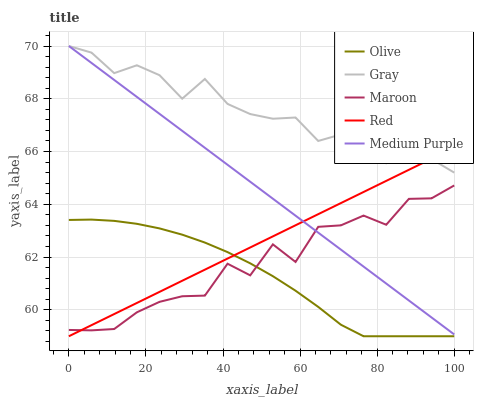Does Medium Purple have the minimum area under the curve?
Answer yes or no. No. Does Medium Purple have the maximum area under the curve?
Answer yes or no. No. Is Gray the smoothest?
Answer yes or no. No. Is Gray the roughest?
Answer yes or no. No. Does Medium Purple have the lowest value?
Answer yes or no. No. Does Red have the highest value?
Answer yes or no. No. Is Olive less than Gray?
Answer yes or no. Yes. Is Gray greater than Maroon?
Answer yes or no. Yes. Does Olive intersect Gray?
Answer yes or no. No. 